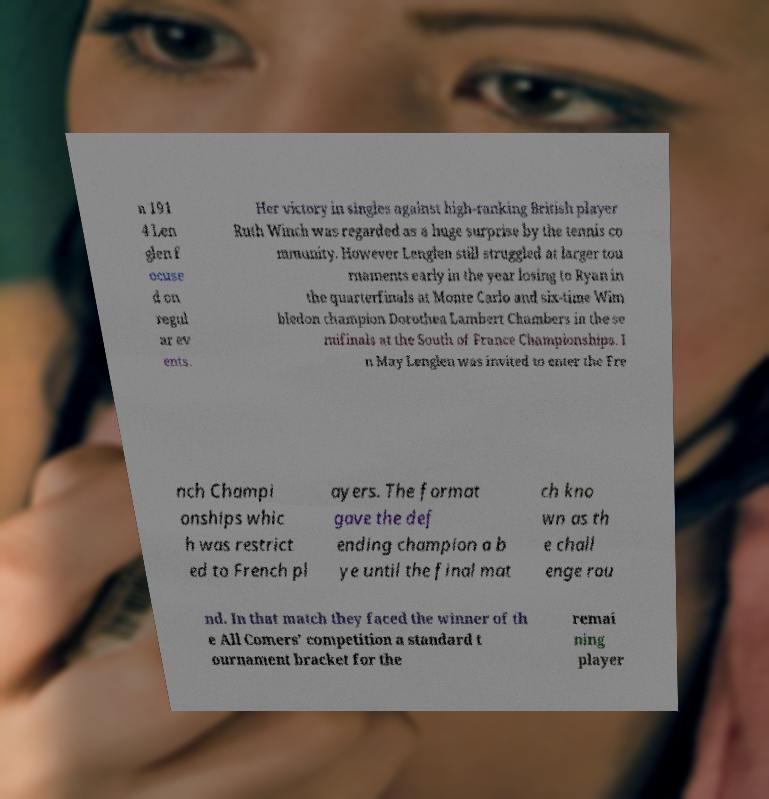Can you accurately transcribe the text from the provided image for me? n 191 4 Len glen f ocuse d on regul ar ev ents. Her victory in singles against high-ranking British player Ruth Winch was regarded as a huge surprise by the tennis co mmunity. However Lenglen still struggled at larger tou rnaments early in the year losing to Ryan in the quarterfinals at Monte Carlo and six-time Wim bledon champion Dorothea Lambert Chambers in the se mifinals at the South of France Championships. I n May Lenglen was invited to enter the Fre nch Champi onships whic h was restrict ed to French pl ayers. The format gave the def ending champion a b ye until the final mat ch kno wn as th e chall enge rou nd. In that match they faced the winner of th e All Comers' competition a standard t ournament bracket for the remai ning player 